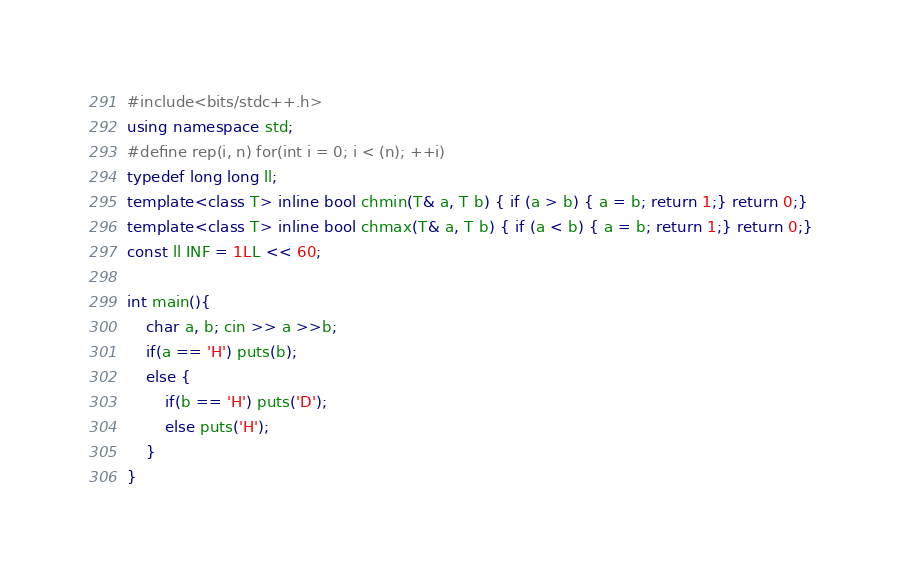Convert code to text. <code><loc_0><loc_0><loc_500><loc_500><_C++_>#include<bits/stdc++.h>
using namespace std;
#define rep(i, n) for(int i = 0; i < (n); ++i)
typedef long long ll;
template<class T> inline bool chmin(T& a, T b) { if (a > b) { a = b; return 1;} return 0;}
template<class T> inline bool chmax(T& a, T b) { if (a < b) { a = b; return 1;} return 0;}
const ll INF = 1LL << 60;

int main(){
	char a, b; cin >> a >>b;
	if(a == 'H') puts(b);
	else {
		if(b == 'H') puts('D');
		else puts('H');
	}
}
</code> 